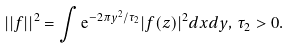<formula> <loc_0><loc_0><loc_500><loc_500>| | f | | ^ { 2 } = \int { \mathrm e } ^ { - 2 \pi y ^ { 2 } / \tau _ { 2 } } | f ( z ) | ^ { 2 } d x d y , \, \tau _ { 2 } > 0 .</formula> 